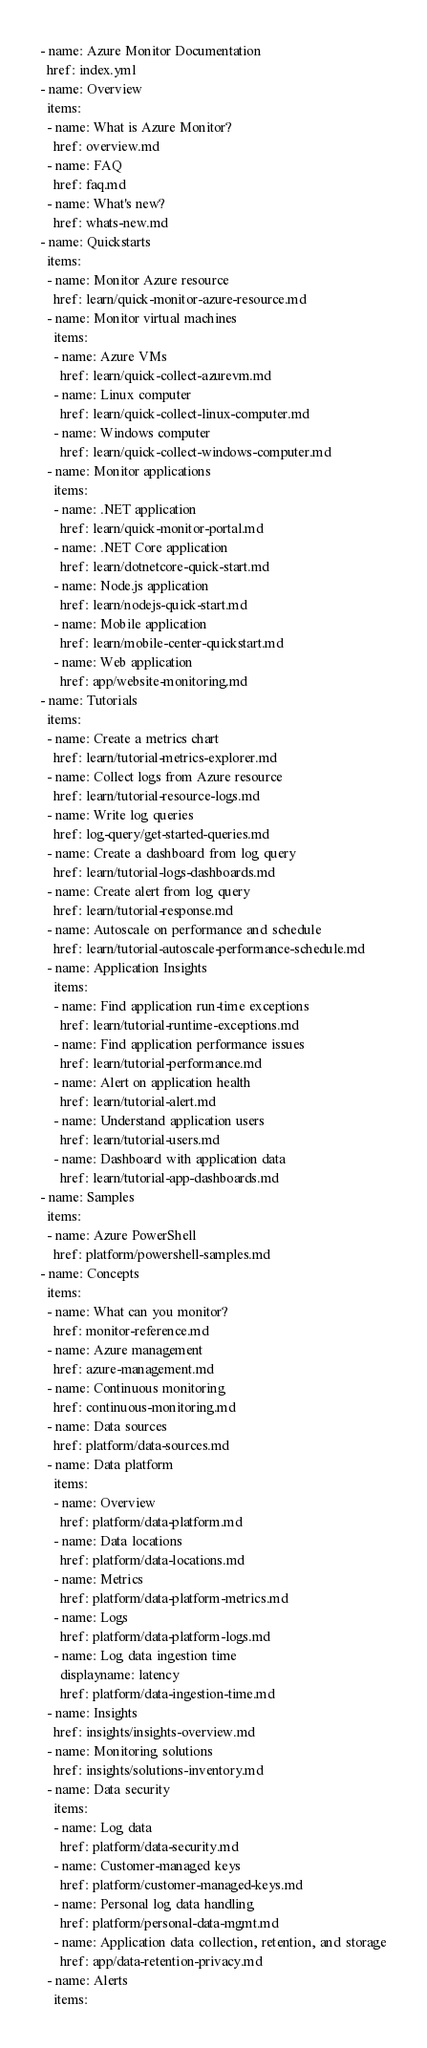<code> <loc_0><loc_0><loc_500><loc_500><_YAML_>- name: Azure Monitor Documentation
  href: index.yml
- name: Overview 
  items:
  - name: What is Azure Monitor?
    href: overview.md
  - name: FAQ
    href: faq.md
  - name: What's new?
    href: whats-new.md
- name: Quickstarts
  items:
  - name: Monitor Azure resource
    href: learn/quick-monitor-azure-resource.md
  - name: Monitor virtual machines
    items:
    - name: Azure VMs
      href: learn/quick-collect-azurevm.md
    - name: Linux computer
      href: learn/quick-collect-linux-computer.md
    - name: Windows computer
      href: learn/quick-collect-windows-computer.md
  - name: Monitor applications
    items:
    - name: .NET application
      href: learn/quick-monitor-portal.md
    - name: .NET Core application
      href: learn/dotnetcore-quick-start.md
    - name: Node.js application
      href: learn/nodejs-quick-start.md
    - name: Mobile application
      href: learn/mobile-center-quickstart.md
    - name: Web application
      href: app/website-monitoring.md 
- name: Tutorials
  items:
  - name: Create a metrics chart
    href: learn/tutorial-metrics-explorer.md
  - name: Collect logs from Azure resource
    href: learn/tutorial-resource-logs.md
  - name: Write log queries
    href: log-query/get-started-queries.md
  - name: Create a dashboard from log query
    href: learn/tutorial-logs-dashboards.md
  - name: Create alert from log query
    href: learn/tutorial-response.md
  - name: Autoscale on performance and schedule
    href: learn/tutorial-autoscale-performance-schedule.md
  - name: Application Insights
    items:  
    - name: Find application run-time exceptions
      href: learn/tutorial-runtime-exceptions.md
    - name: Find application performance issues
      href: learn/tutorial-performance.md
    - name: Alert on application health
      href: learn/tutorial-alert.md
    - name: Understand application users
      href: learn/tutorial-users.md
    - name: Dashboard with application data
      href: learn/tutorial-app-dashboards.md
- name: Samples
  items:
  - name: Azure PowerShell
    href: platform/powershell-samples.md
- name: Concepts
  items:
  - name: What can you monitor?
    href: monitor-reference.md
  - name: Azure management
    href: azure-management.md
  - name: Continuous monitoring
    href: continuous-monitoring.md
  - name: Data sources
    href: platform/data-sources.md
  - name: Data platform
    items:
    - name: Overview
      href: platform/data-platform.md
    - name: Data locations
      href: platform/data-locations.md
    - name: Metrics
      href: platform/data-platform-metrics.md
    - name: Logs
      href: platform/data-platform-logs.md
    - name: Log data ingestion time
      displayname: latency
      href: platform/data-ingestion-time.md         
  - name: Insights
    href: insights/insights-overview.md
  - name: Monitoring solutions
    href: insights/solutions-inventory.md
  - name: Data security
    items:
    - name: Log data
      href: platform/data-security.md
    - name: Customer-managed keys
      href: platform/customer-managed-keys.md
    - name: Personal log data handling
      href: platform/personal-data-mgmt.md
    - name: Application data collection, retention, and storage
      href: app/data-retention-privacy.md
  - name: Alerts
    items:</code> 